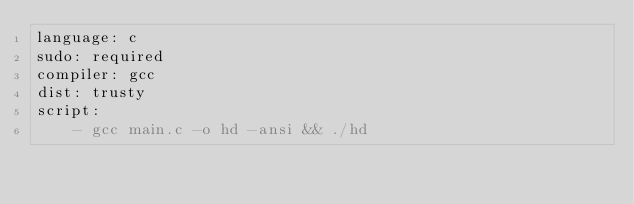<code> <loc_0><loc_0><loc_500><loc_500><_YAML_>language: c
sudo: required
compiler: gcc
dist: trusty
script:
    - gcc main.c -o hd -ansi && ./hd
</code> 